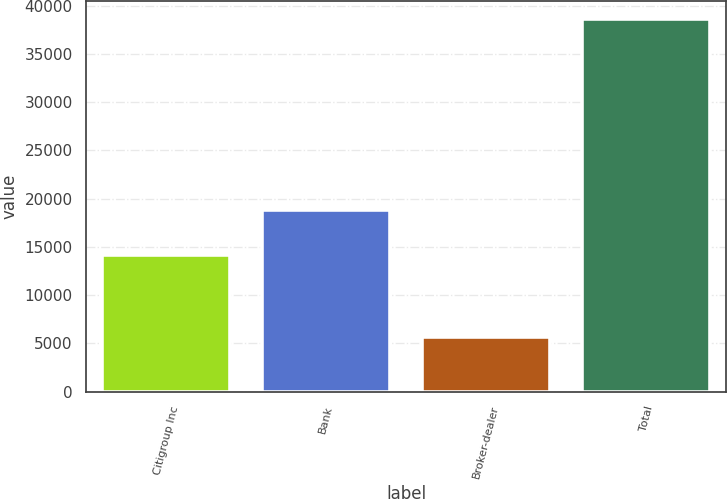Convert chart to OTSL. <chart><loc_0><loc_0><loc_500><loc_500><bar_chart><fcel>Citigroup Inc<fcel>Bank<fcel>Broker-dealer<fcel>Total<nl><fcel>14144<fcel>18809<fcel>5637<fcel>38590<nl></chart> 